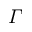Convert formula to latex. <formula><loc_0><loc_0><loc_500><loc_500>\varGamma</formula> 